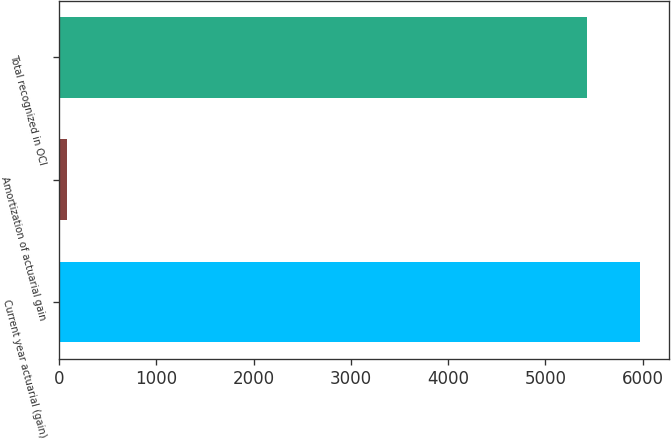Convert chart. <chart><loc_0><loc_0><loc_500><loc_500><bar_chart><fcel>Current year actuarial (gain)<fcel>Amortization of actuarial gain<fcel>Total recognized in OCI<nl><fcel>5973.6<fcel>83<fcel>5428<nl></chart> 